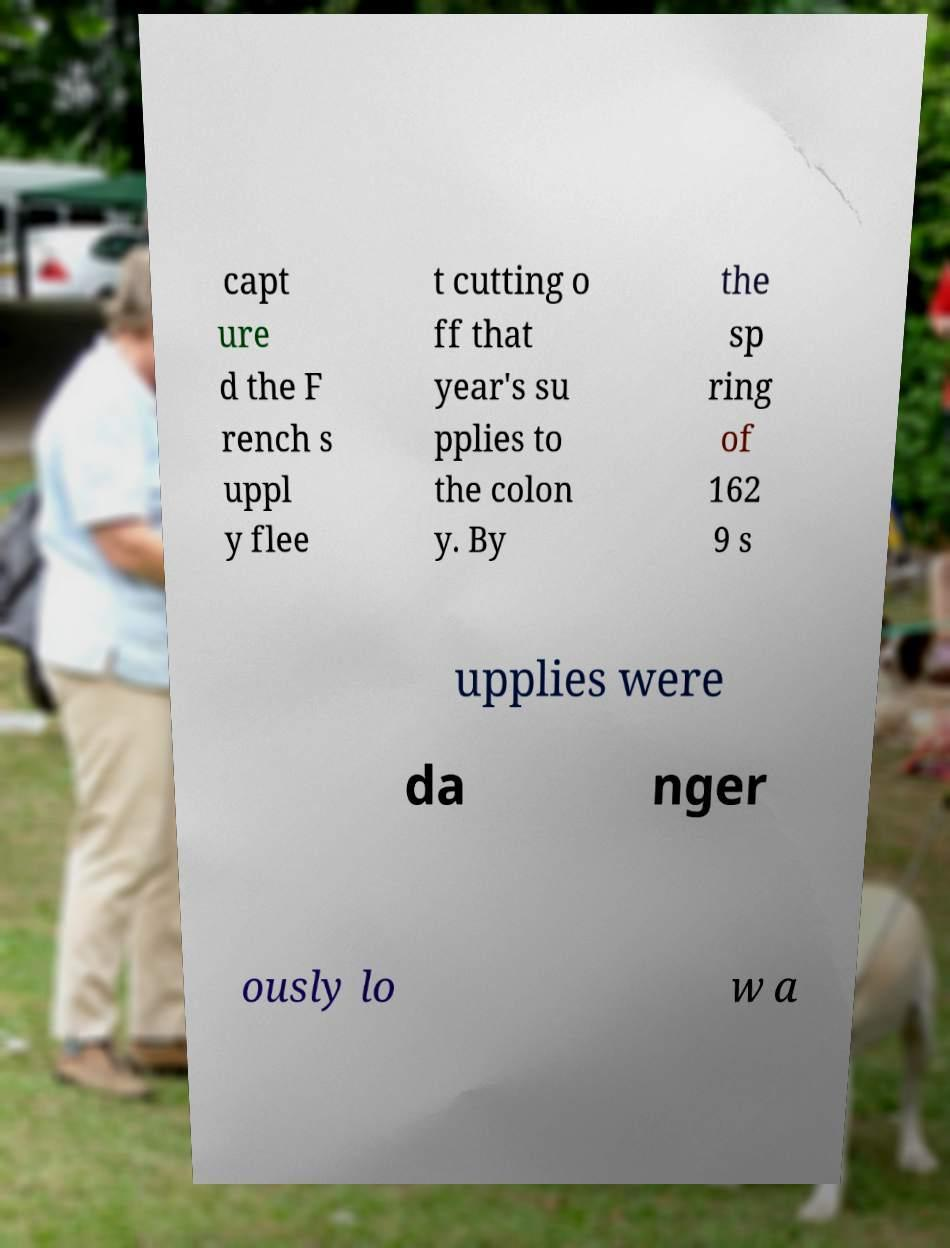What messages or text are displayed in this image? I need them in a readable, typed format. capt ure d the F rench s uppl y flee t cutting o ff that year's su pplies to the colon y. By the sp ring of 162 9 s upplies were da nger ously lo w a 